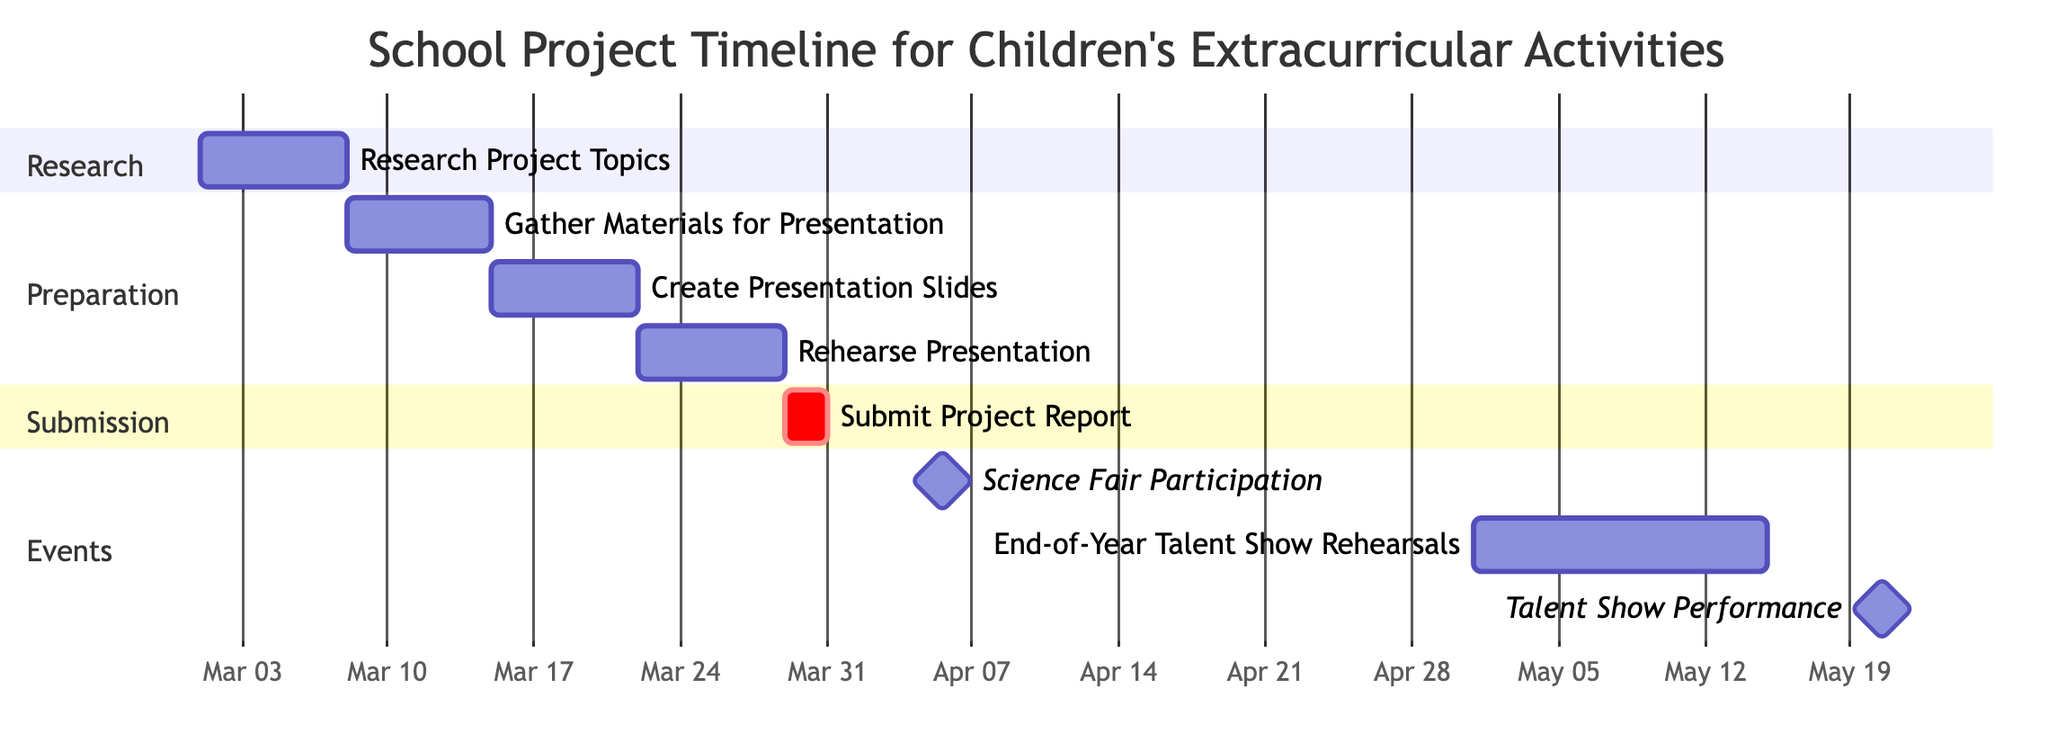What is the duration of the 'Research Project Topics' task? The 'Research Project Topics' task is noted to last for 1 week in the duration field.
Answer: 1 week What are the start and end dates for the 'Talent Show Performance'? The 'Talent Show Performance' begins on April 20, 2024, and ends on the same day, as indicated in the start and end fields.
Answer: April 20, 2024 How many total tasks are listed in the Gantt chart? There are 8 tasks identified in the diagram under different sections, counting each task shows the total is 8.
Answer: 8 What is the next task after 'Rehearse Presentation'? The task that follows 'Rehearse Presentation' is 'Submit Project Report', as indicated by the sequential arrangement of tasks.
Answer: Submit Project Report How many days are allocated for the 'Submit Project Report' task? The task 'Submit Project Report' lasts for 2 days, as shown in the duration field for that task.
Answer: 2 days What is the deadline for the 'Science Fair Participation' event? The deadline for 'Science Fair Participation' is the same day it occurs, April 5, 2024, as marked in the start and end date fields.
Answer: April 5, 2024 What task is scheduled before the 'End-of-Year Talent Show Rehearsals'? The task scheduled before 'End-of-Year Talent Show Rehearsals' is 'Science Fair Participation', which comes before it in the timeline.
Answer: Science Fair Participation How long is the total preparation phase before the submission of the project report? To find the total preparation time, sum the durations of the tasks before the 'Submit Project Report', which equals 4 weeks (1 week each for 4 tasks).
Answer: 4 weeks 